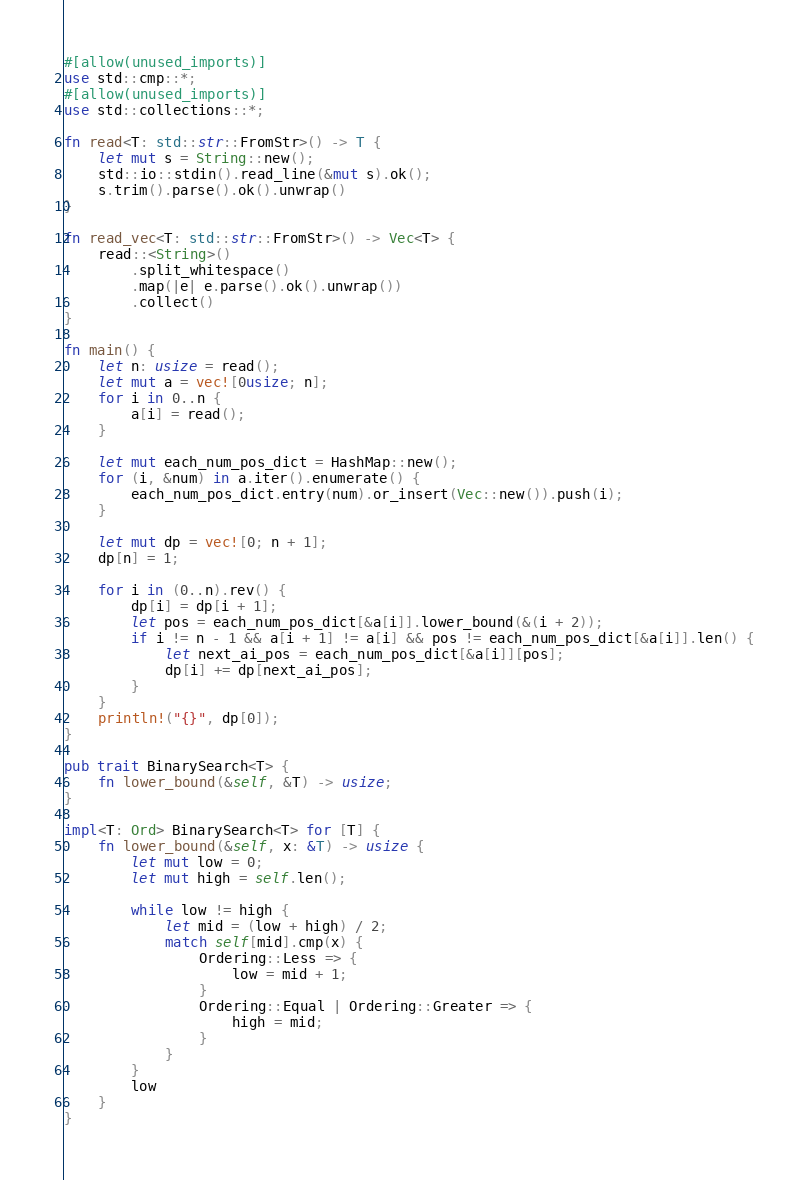<code> <loc_0><loc_0><loc_500><loc_500><_Rust_>#[allow(unused_imports)]
use std::cmp::*;
#[allow(unused_imports)]
use std::collections::*;

fn read<T: std::str::FromStr>() -> T {
    let mut s = String::new();
    std::io::stdin().read_line(&mut s).ok();
    s.trim().parse().ok().unwrap()
}

fn read_vec<T: std::str::FromStr>() -> Vec<T> {
    read::<String>()
        .split_whitespace()
        .map(|e| e.parse().ok().unwrap())
        .collect()
}

fn main() {
    let n: usize = read();
    let mut a = vec![0usize; n];
    for i in 0..n {
        a[i] = read();
    }

    let mut each_num_pos_dict = HashMap::new();
    for (i, &num) in a.iter().enumerate() {
        each_num_pos_dict.entry(num).or_insert(Vec::new()).push(i);
    }

    let mut dp = vec![0; n + 1];
    dp[n] = 1;

    for i in (0..n).rev() {
        dp[i] = dp[i + 1];
        let pos = each_num_pos_dict[&a[i]].lower_bound(&(i + 2));
        if i != n - 1 && a[i + 1] != a[i] && pos != each_num_pos_dict[&a[i]].len() {
            let next_ai_pos = each_num_pos_dict[&a[i]][pos];
            dp[i] += dp[next_ai_pos];
        }
    }
    println!("{}", dp[0]);
}

pub trait BinarySearch<T> {
    fn lower_bound(&self, &T) -> usize;
}

impl<T: Ord> BinarySearch<T> for [T] {
    fn lower_bound(&self, x: &T) -> usize {
        let mut low = 0;
        let mut high = self.len();

        while low != high {
            let mid = (low + high) / 2;
            match self[mid].cmp(x) {
                Ordering::Less => {
                    low = mid + 1;
                }
                Ordering::Equal | Ordering::Greater => {
                    high = mid;
                }
            }
        }
        low
    }
}
</code> 